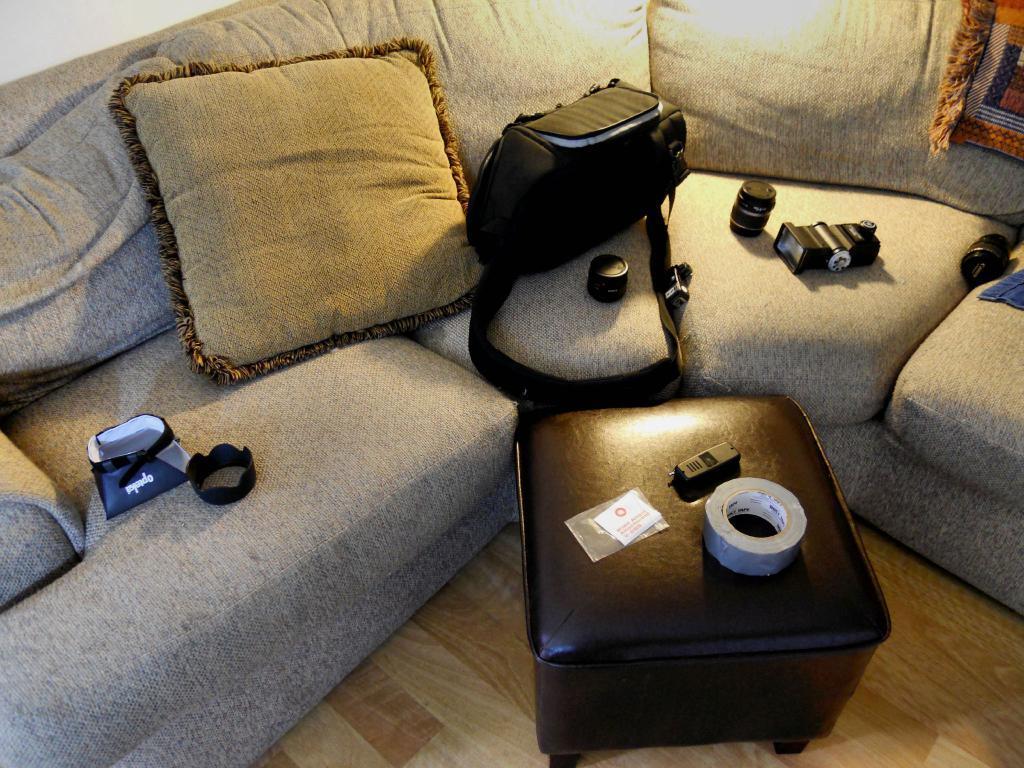Can you describe this image briefly? In this picture we can see a sofa, table on the floor, here we can see bags, pillow, cloth, plaster roll, camera and some objects. 